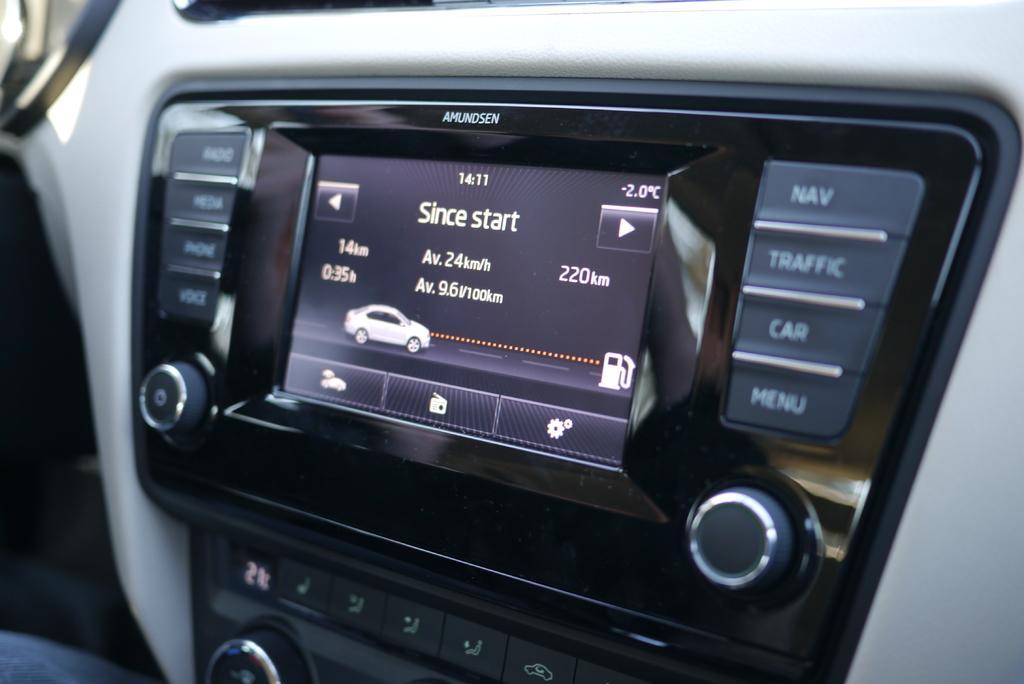In one or two sentences, can you explain what this image depicts? In this picture we can see the digital car cluster with some buttons. 